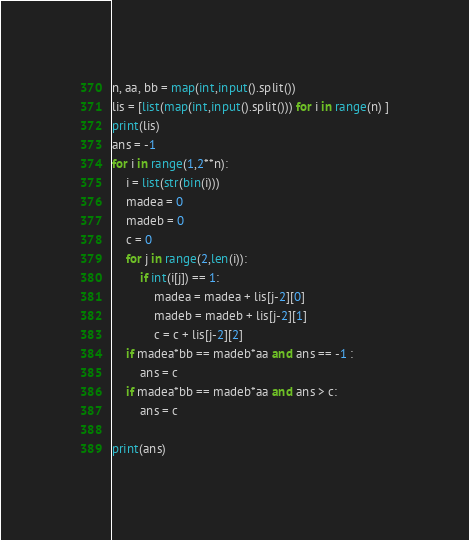<code> <loc_0><loc_0><loc_500><loc_500><_Python_>n, aa, bb = map(int,input().split())
lis = [list(map(int,input().split())) for i in range(n) ]
print(lis)
ans = -1
for i in range(1,2**n):
    i = list(str(bin(i)))
    madea = 0
    madeb = 0
    c = 0
    for j in range(2,len(i)):
        if int(i[j]) == 1:
            madea = madea + lis[j-2][0]
            madeb = madeb + lis[j-2][1]
            c = c + lis[j-2][2]
    if madea*bb == madeb*aa and ans == -1 :
        ans = c
    if madea*bb == madeb*aa and ans > c:
        ans = c

print(ans)</code> 